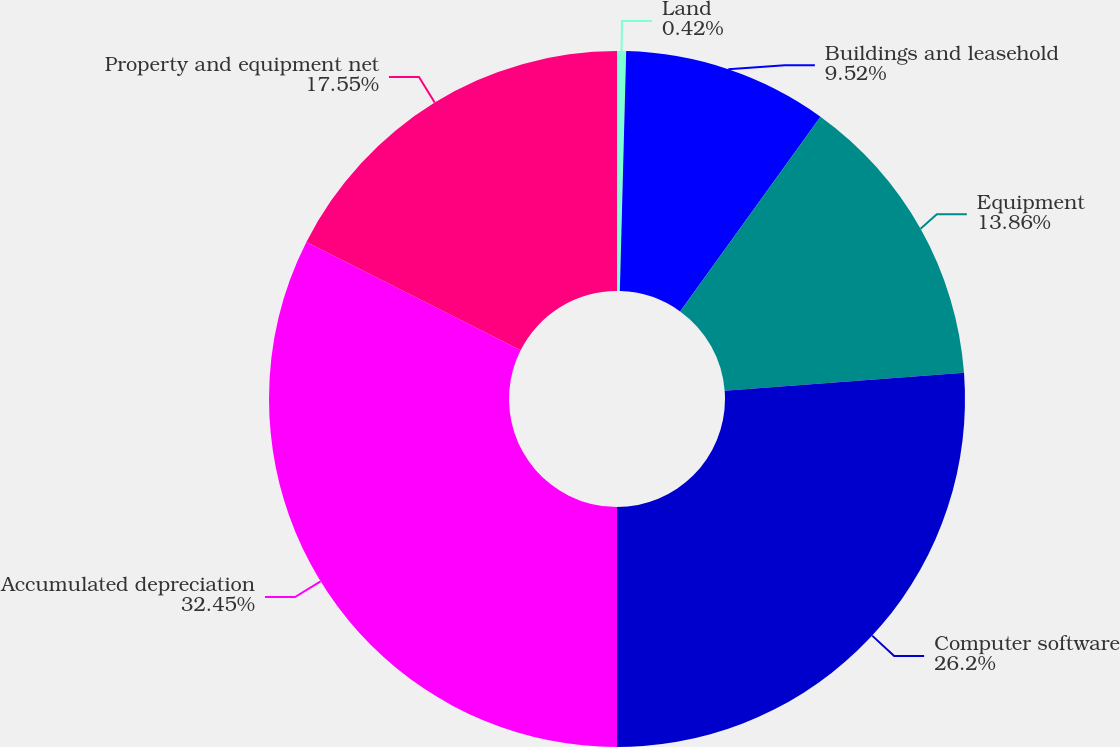Convert chart to OTSL. <chart><loc_0><loc_0><loc_500><loc_500><pie_chart><fcel>Land<fcel>Buildings and leasehold<fcel>Equipment<fcel>Computer software<fcel>Accumulated depreciation<fcel>Property and equipment net<nl><fcel>0.42%<fcel>9.52%<fcel>13.86%<fcel>26.2%<fcel>32.45%<fcel>17.55%<nl></chart> 